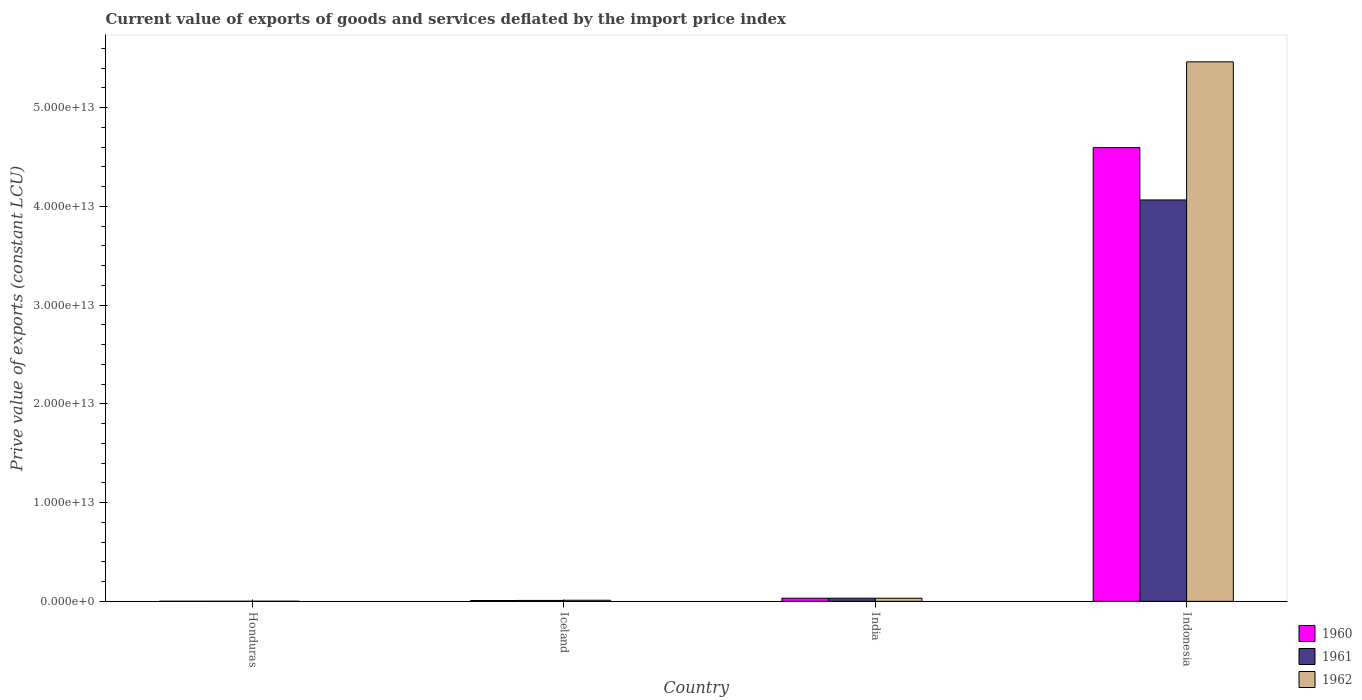How many bars are there on the 1st tick from the left?
Your answer should be very brief. 3. How many bars are there on the 2nd tick from the right?
Provide a succinct answer. 3. What is the label of the 4th group of bars from the left?
Ensure brevity in your answer.  Indonesia. In how many cases, is the number of bars for a given country not equal to the number of legend labels?
Provide a succinct answer. 0. What is the prive value of exports in 1960 in Honduras?
Your response must be concise. 1.07e+1. Across all countries, what is the maximum prive value of exports in 1962?
Offer a terse response. 5.46e+13. Across all countries, what is the minimum prive value of exports in 1960?
Give a very brief answer. 1.07e+1. In which country was the prive value of exports in 1961 minimum?
Give a very brief answer. Honduras. What is the total prive value of exports in 1960 in the graph?
Offer a terse response. 4.64e+13. What is the difference between the prive value of exports in 1960 in Iceland and that in Indonesia?
Offer a very short reply. -4.59e+13. What is the difference between the prive value of exports in 1961 in India and the prive value of exports in 1962 in Honduras?
Keep it short and to the point. 3.07e+11. What is the average prive value of exports in 1960 per country?
Provide a short and direct response. 1.16e+13. What is the difference between the prive value of exports of/in 1962 and prive value of exports of/in 1960 in Honduras?
Your response must be concise. 2.43e+09. In how many countries, is the prive value of exports in 1961 greater than 28000000000000 LCU?
Keep it short and to the point. 1. What is the ratio of the prive value of exports in 1962 in Honduras to that in Iceland?
Keep it short and to the point. 0.12. Is the prive value of exports in 1962 in Honduras less than that in Iceland?
Provide a succinct answer. Yes. Is the difference between the prive value of exports in 1962 in Iceland and India greater than the difference between the prive value of exports in 1960 in Iceland and India?
Keep it short and to the point. Yes. What is the difference between the highest and the second highest prive value of exports in 1961?
Make the answer very short. 4.03e+13. What is the difference between the highest and the lowest prive value of exports in 1962?
Offer a terse response. 5.46e+13. What does the 2nd bar from the right in Indonesia represents?
Offer a terse response. 1961. How many bars are there?
Your answer should be very brief. 12. How many countries are there in the graph?
Give a very brief answer. 4. What is the difference between two consecutive major ticks on the Y-axis?
Provide a short and direct response. 1.00e+13. Where does the legend appear in the graph?
Offer a very short reply. Bottom right. How are the legend labels stacked?
Give a very brief answer. Vertical. What is the title of the graph?
Your answer should be compact. Current value of exports of goods and services deflated by the import price index. What is the label or title of the X-axis?
Your answer should be very brief. Country. What is the label or title of the Y-axis?
Offer a very short reply. Prive value of exports (constant LCU). What is the Prive value of exports (constant LCU) in 1960 in Honduras?
Your answer should be very brief. 1.07e+1. What is the Prive value of exports (constant LCU) in 1961 in Honduras?
Your answer should be very brief. 1.19e+1. What is the Prive value of exports (constant LCU) in 1962 in Honduras?
Keep it short and to the point. 1.31e+1. What is the Prive value of exports (constant LCU) in 1960 in Iceland?
Ensure brevity in your answer.  8.60e+1. What is the Prive value of exports (constant LCU) of 1961 in Iceland?
Offer a very short reply. 9.34e+1. What is the Prive value of exports (constant LCU) of 1962 in Iceland?
Make the answer very short. 1.12e+11. What is the Prive value of exports (constant LCU) in 1960 in India?
Your answer should be compact. 3.21e+11. What is the Prive value of exports (constant LCU) in 1961 in India?
Give a very brief answer. 3.20e+11. What is the Prive value of exports (constant LCU) in 1962 in India?
Provide a short and direct response. 3.19e+11. What is the Prive value of exports (constant LCU) of 1960 in Indonesia?
Keep it short and to the point. 4.60e+13. What is the Prive value of exports (constant LCU) in 1961 in Indonesia?
Provide a succinct answer. 4.07e+13. What is the Prive value of exports (constant LCU) in 1962 in Indonesia?
Keep it short and to the point. 5.46e+13. Across all countries, what is the maximum Prive value of exports (constant LCU) of 1960?
Your answer should be very brief. 4.60e+13. Across all countries, what is the maximum Prive value of exports (constant LCU) in 1961?
Your answer should be compact. 4.07e+13. Across all countries, what is the maximum Prive value of exports (constant LCU) in 1962?
Your answer should be very brief. 5.46e+13. Across all countries, what is the minimum Prive value of exports (constant LCU) of 1960?
Make the answer very short. 1.07e+1. Across all countries, what is the minimum Prive value of exports (constant LCU) in 1961?
Keep it short and to the point. 1.19e+1. Across all countries, what is the minimum Prive value of exports (constant LCU) in 1962?
Offer a terse response. 1.31e+1. What is the total Prive value of exports (constant LCU) in 1960 in the graph?
Provide a succinct answer. 4.64e+13. What is the total Prive value of exports (constant LCU) of 1961 in the graph?
Give a very brief answer. 4.11e+13. What is the total Prive value of exports (constant LCU) of 1962 in the graph?
Provide a succinct answer. 5.51e+13. What is the difference between the Prive value of exports (constant LCU) of 1960 in Honduras and that in Iceland?
Ensure brevity in your answer.  -7.54e+1. What is the difference between the Prive value of exports (constant LCU) in 1961 in Honduras and that in Iceland?
Provide a succinct answer. -8.14e+1. What is the difference between the Prive value of exports (constant LCU) of 1962 in Honduras and that in Iceland?
Make the answer very short. -9.94e+1. What is the difference between the Prive value of exports (constant LCU) of 1960 in Honduras and that in India?
Offer a terse response. -3.10e+11. What is the difference between the Prive value of exports (constant LCU) of 1961 in Honduras and that in India?
Your answer should be compact. -3.08e+11. What is the difference between the Prive value of exports (constant LCU) of 1962 in Honduras and that in India?
Ensure brevity in your answer.  -3.05e+11. What is the difference between the Prive value of exports (constant LCU) of 1960 in Honduras and that in Indonesia?
Your answer should be compact. -4.59e+13. What is the difference between the Prive value of exports (constant LCU) in 1961 in Honduras and that in Indonesia?
Offer a terse response. -4.06e+13. What is the difference between the Prive value of exports (constant LCU) in 1962 in Honduras and that in Indonesia?
Keep it short and to the point. -5.46e+13. What is the difference between the Prive value of exports (constant LCU) of 1960 in Iceland and that in India?
Provide a short and direct response. -2.35e+11. What is the difference between the Prive value of exports (constant LCU) in 1961 in Iceland and that in India?
Your answer should be very brief. -2.27e+11. What is the difference between the Prive value of exports (constant LCU) of 1962 in Iceland and that in India?
Give a very brief answer. -2.06e+11. What is the difference between the Prive value of exports (constant LCU) in 1960 in Iceland and that in Indonesia?
Offer a terse response. -4.59e+13. What is the difference between the Prive value of exports (constant LCU) of 1961 in Iceland and that in Indonesia?
Keep it short and to the point. -4.06e+13. What is the difference between the Prive value of exports (constant LCU) in 1962 in Iceland and that in Indonesia?
Your answer should be compact. -5.45e+13. What is the difference between the Prive value of exports (constant LCU) of 1960 in India and that in Indonesia?
Offer a very short reply. -4.56e+13. What is the difference between the Prive value of exports (constant LCU) in 1961 in India and that in Indonesia?
Ensure brevity in your answer.  -4.03e+13. What is the difference between the Prive value of exports (constant LCU) of 1962 in India and that in Indonesia?
Offer a very short reply. -5.43e+13. What is the difference between the Prive value of exports (constant LCU) in 1960 in Honduras and the Prive value of exports (constant LCU) in 1961 in Iceland?
Offer a very short reply. -8.27e+1. What is the difference between the Prive value of exports (constant LCU) of 1960 in Honduras and the Prive value of exports (constant LCU) of 1962 in Iceland?
Offer a very short reply. -1.02e+11. What is the difference between the Prive value of exports (constant LCU) of 1961 in Honduras and the Prive value of exports (constant LCU) of 1962 in Iceland?
Give a very brief answer. -1.01e+11. What is the difference between the Prive value of exports (constant LCU) of 1960 in Honduras and the Prive value of exports (constant LCU) of 1961 in India?
Ensure brevity in your answer.  -3.10e+11. What is the difference between the Prive value of exports (constant LCU) in 1960 in Honduras and the Prive value of exports (constant LCU) in 1962 in India?
Ensure brevity in your answer.  -3.08e+11. What is the difference between the Prive value of exports (constant LCU) of 1961 in Honduras and the Prive value of exports (constant LCU) of 1962 in India?
Offer a very short reply. -3.07e+11. What is the difference between the Prive value of exports (constant LCU) in 1960 in Honduras and the Prive value of exports (constant LCU) in 1961 in Indonesia?
Your answer should be compact. -4.06e+13. What is the difference between the Prive value of exports (constant LCU) in 1960 in Honduras and the Prive value of exports (constant LCU) in 1962 in Indonesia?
Provide a short and direct response. -5.46e+13. What is the difference between the Prive value of exports (constant LCU) of 1961 in Honduras and the Prive value of exports (constant LCU) of 1962 in Indonesia?
Your response must be concise. -5.46e+13. What is the difference between the Prive value of exports (constant LCU) in 1960 in Iceland and the Prive value of exports (constant LCU) in 1961 in India?
Your answer should be very brief. -2.34e+11. What is the difference between the Prive value of exports (constant LCU) of 1960 in Iceland and the Prive value of exports (constant LCU) of 1962 in India?
Keep it short and to the point. -2.32e+11. What is the difference between the Prive value of exports (constant LCU) of 1961 in Iceland and the Prive value of exports (constant LCU) of 1962 in India?
Make the answer very short. -2.25e+11. What is the difference between the Prive value of exports (constant LCU) in 1960 in Iceland and the Prive value of exports (constant LCU) in 1961 in Indonesia?
Provide a succinct answer. -4.06e+13. What is the difference between the Prive value of exports (constant LCU) in 1960 in Iceland and the Prive value of exports (constant LCU) in 1962 in Indonesia?
Ensure brevity in your answer.  -5.45e+13. What is the difference between the Prive value of exports (constant LCU) of 1961 in Iceland and the Prive value of exports (constant LCU) of 1962 in Indonesia?
Your response must be concise. -5.45e+13. What is the difference between the Prive value of exports (constant LCU) of 1960 in India and the Prive value of exports (constant LCU) of 1961 in Indonesia?
Provide a succinct answer. -4.03e+13. What is the difference between the Prive value of exports (constant LCU) of 1960 in India and the Prive value of exports (constant LCU) of 1962 in Indonesia?
Offer a terse response. -5.43e+13. What is the difference between the Prive value of exports (constant LCU) of 1961 in India and the Prive value of exports (constant LCU) of 1962 in Indonesia?
Offer a terse response. -5.43e+13. What is the average Prive value of exports (constant LCU) in 1960 per country?
Make the answer very short. 1.16e+13. What is the average Prive value of exports (constant LCU) in 1961 per country?
Ensure brevity in your answer.  1.03e+13. What is the average Prive value of exports (constant LCU) in 1962 per country?
Offer a very short reply. 1.38e+13. What is the difference between the Prive value of exports (constant LCU) in 1960 and Prive value of exports (constant LCU) in 1961 in Honduras?
Provide a short and direct response. -1.27e+09. What is the difference between the Prive value of exports (constant LCU) of 1960 and Prive value of exports (constant LCU) of 1962 in Honduras?
Your response must be concise. -2.43e+09. What is the difference between the Prive value of exports (constant LCU) in 1961 and Prive value of exports (constant LCU) in 1962 in Honduras?
Ensure brevity in your answer.  -1.15e+09. What is the difference between the Prive value of exports (constant LCU) of 1960 and Prive value of exports (constant LCU) of 1961 in Iceland?
Your answer should be compact. -7.34e+09. What is the difference between the Prive value of exports (constant LCU) in 1960 and Prive value of exports (constant LCU) in 1962 in Iceland?
Provide a succinct answer. -2.64e+1. What is the difference between the Prive value of exports (constant LCU) in 1961 and Prive value of exports (constant LCU) in 1962 in Iceland?
Make the answer very short. -1.91e+1. What is the difference between the Prive value of exports (constant LCU) of 1960 and Prive value of exports (constant LCU) of 1961 in India?
Offer a terse response. 5.97e+08. What is the difference between the Prive value of exports (constant LCU) in 1960 and Prive value of exports (constant LCU) in 1962 in India?
Offer a terse response. 2.45e+09. What is the difference between the Prive value of exports (constant LCU) in 1961 and Prive value of exports (constant LCU) in 1962 in India?
Provide a short and direct response. 1.86e+09. What is the difference between the Prive value of exports (constant LCU) in 1960 and Prive value of exports (constant LCU) in 1961 in Indonesia?
Offer a terse response. 5.30e+12. What is the difference between the Prive value of exports (constant LCU) of 1960 and Prive value of exports (constant LCU) of 1962 in Indonesia?
Give a very brief answer. -8.68e+12. What is the difference between the Prive value of exports (constant LCU) in 1961 and Prive value of exports (constant LCU) in 1962 in Indonesia?
Your answer should be compact. -1.40e+13. What is the ratio of the Prive value of exports (constant LCU) of 1960 in Honduras to that in Iceland?
Your answer should be compact. 0.12. What is the ratio of the Prive value of exports (constant LCU) of 1961 in Honduras to that in Iceland?
Provide a succinct answer. 0.13. What is the ratio of the Prive value of exports (constant LCU) in 1962 in Honduras to that in Iceland?
Your response must be concise. 0.12. What is the ratio of the Prive value of exports (constant LCU) in 1960 in Honduras to that in India?
Offer a very short reply. 0.03. What is the ratio of the Prive value of exports (constant LCU) in 1961 in Honduras to that in India?
Make the answer very short. 0.04. What is the ratio of the Prive value of exports (constant LCU) of 1962 in Honduras to that in India?
Offer a terse response. 0.04. What is the ratio of the Prive value of exports (constant LCU) in 1960 in Honduras to that in Indonesia?
Your answer should be compact. 0. What is the ratio of the Prive value of exports (constant LCU) in 1961 in Honduras to that in Indonesia?
Offer a terse response. 0. What is the ratio of the Prive value of exports (constant LCU) in 1960 in Iceland to that in India?
Provide a short and direct response. 0.27. What is the ratio of the Prive value of exports (constant LCU) in 1961 in Iceland to that in India?
Your response must be concise. 0.29. What is the ratio of the Prive value of exports (constant LCU) of 1962 in Iceland to that in India?
Your answer should be compact. 0.35. What is the ratio of the Prive value of exports (constant LCU) in 1960 in Iceland to that in Indonesia?
Provide a succinct answer. 0. What is the ratio of the Prive value of exports (constant LCU) of 1961 in Iceland to that in Indonesia?
Offer a terse response. 0. What is the ratio of the Prive value of exports (constant LCU) in 1962 in Iceland to that in Indonesia?
Offer a terse response. 0. What is the ratio of the Prive value of exports (constant LCU) in 1960 in India to that in Indonesia?
Offer a very short reply. 0.01. What is the ratio of the Prive value of exports (constant LCU) in 1961 in India to that in Indonesia?
Your response must be concise. 0.01. What is the ratio of the Prive value of exports (constant LCU) of 1962 in India to that in Indonesia?
Ensure brevity in your answer.  0.01. What is the difference between the highest and the second highest Prive value of exports (constant LCU) of 1960?
Provide a short and direct response. 4.56e+13. What is the difference between the highest and the second highest Prive value of exports (constant LCU) of 1961?
Offer a very short reply. 4.03e+13. What is the difference between the highest and the second highest Prive value of exports (constant LCU) in 1962?
Your answer should be very brief. 5.43e+13. What is the difference between the highest and the lowest Prive value of exports (constant LCU) in 1960?
Ensure brevity in your answer.  4.59e+13. What is the difference between the highest and the lowest Prive value of exports (constant LCU) of 1961?
Offer a very short reply. 4.06e+13. What is the difference between the highest and the lowest Prive value of exports (constant LCU) in 1962?
Your answer should be very brief. 5.46e+13. 